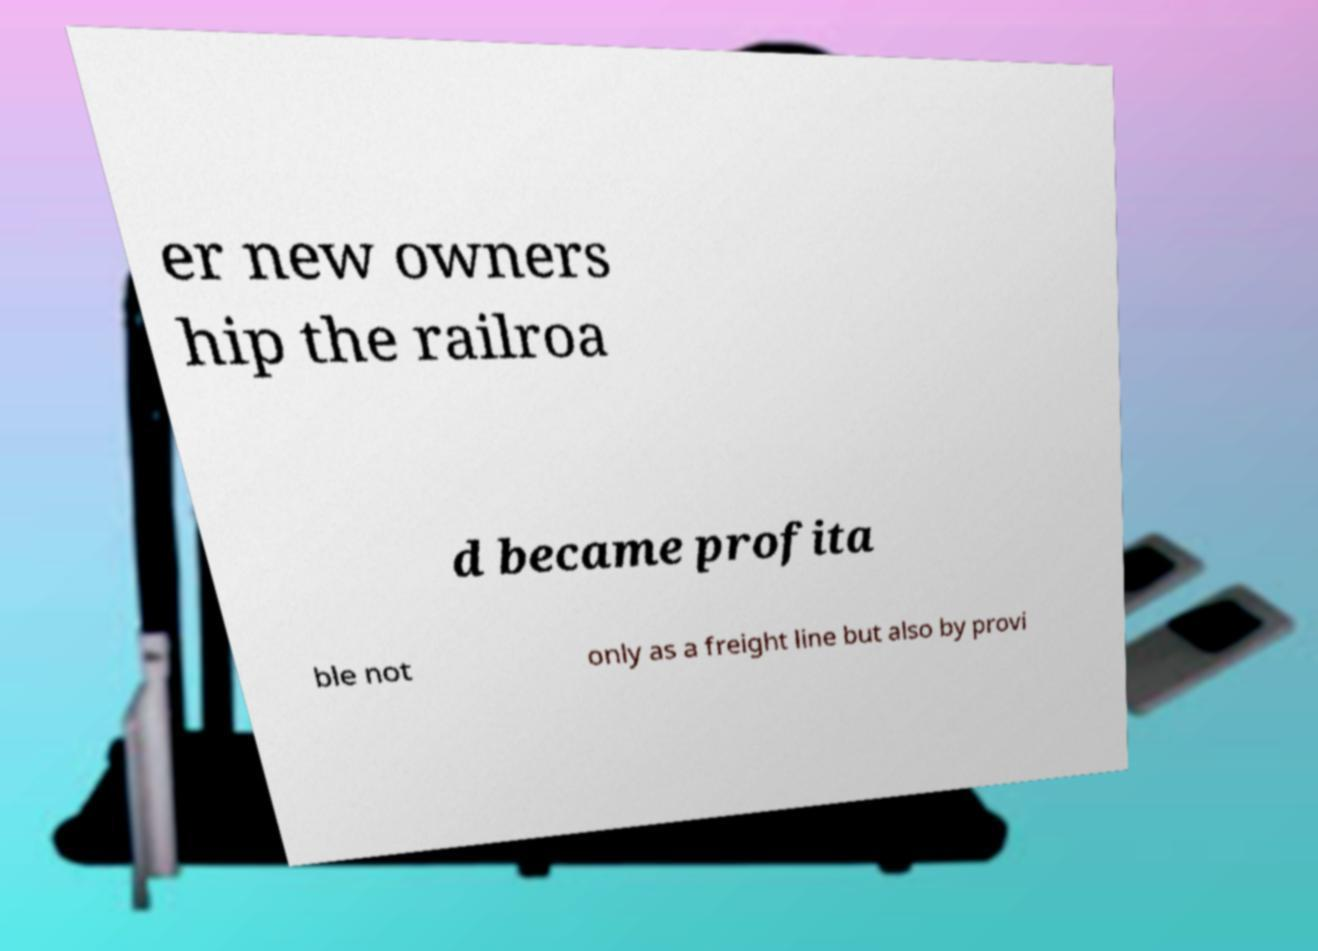For documentation purposes, I need the text within this image transcribed. Could you provide that? er new owners hip the railroa d became profita ble not only as a freight line but also by provi 